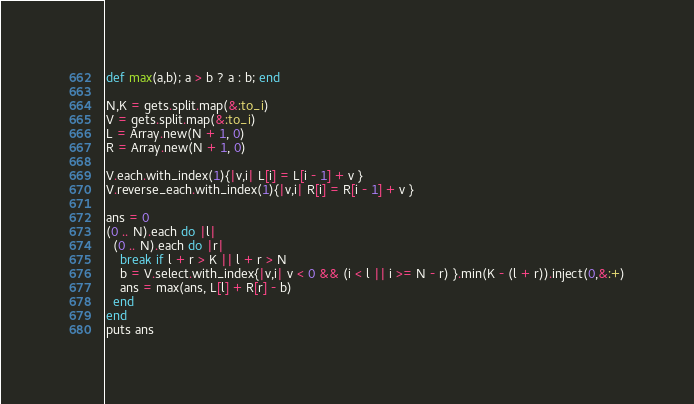<code> <loc_0><loc_0><loc_500><loc_500><_Ruby_>def max(a,b); a > b ? a : b; end
  
N,K = gets.split.map(&:to_i)
V = gets.split.map(&:to_i)
L = Array.new(N + 1, 0)
R = Array.new(N + 1, 0)

V.each.with_index(1){|v,i| L[i] = L[i - 1] + v }
V.reverse_each.with_index(1){|v,i| R[i] = R[i - 1] + v }

ans = 0
(0 .. N).each do |l|
  (0 .. N).each do |r|
    break if l + r > K || l + r > N
    b = V.select.with_index{|v,i| v < 0 && (i < l || i >= N - r) }.min(K - (l + r)).inject(0,&:+)
    ans = max(ans, L[l] + R[r] - b)
  end
end
puts ans
</code> 